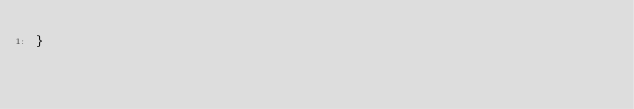Convert code to text. <code><loc_0><loc_0><loc_500><loc_500><_JavaScript_>}
</code> 